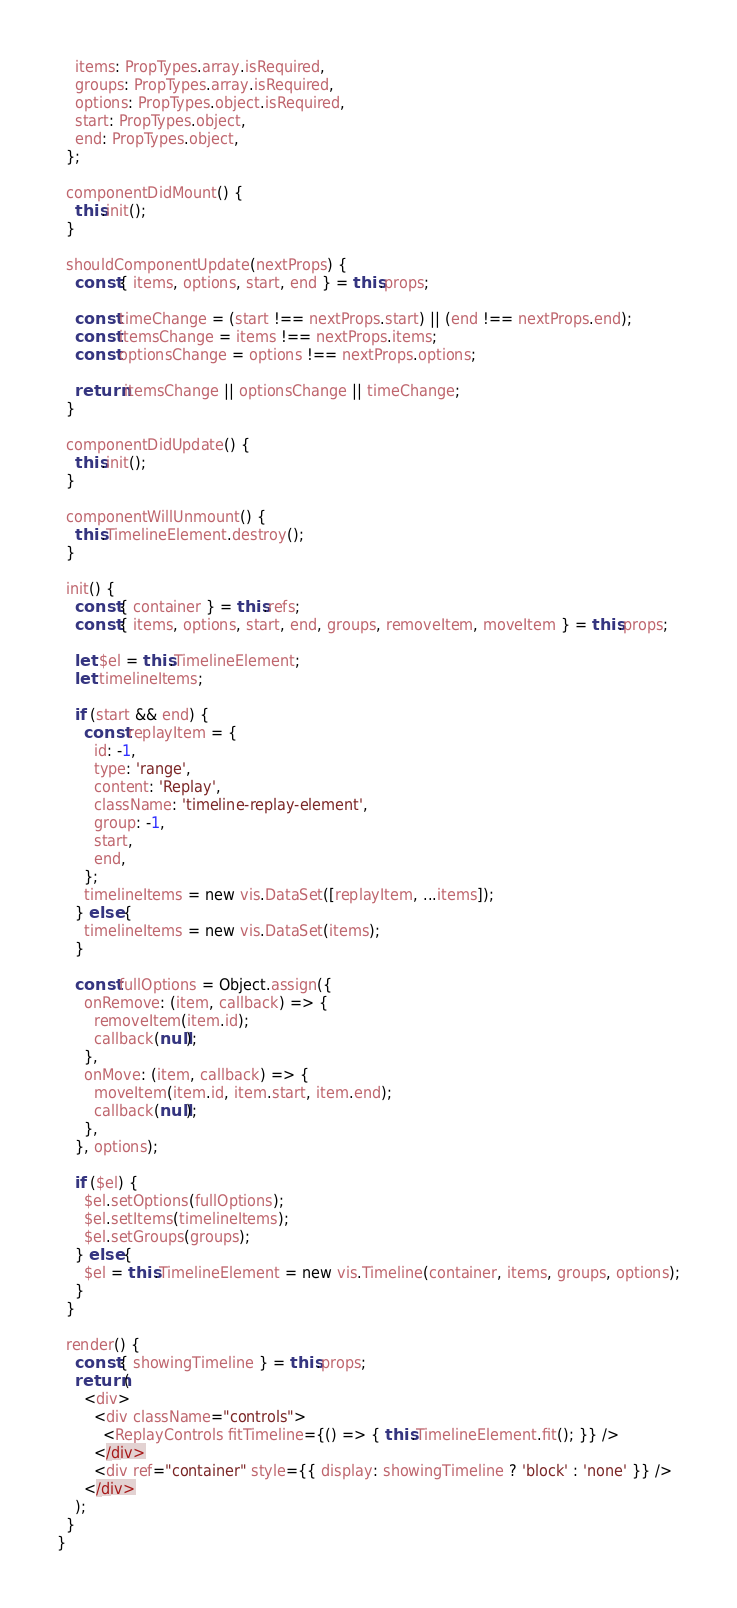<code> <loc_0><loc_0><loc_500><loc_500><_JavaScript_>    items: PropTypes.array.isRequired,
    groups: PropTypes.array.isRequired,
    options: PropTypes.object.isRequired,
    start: PropTypes.object,
    end: PropTypes.object,
  };

  componentDidMount() {
    this.init();
  }

  shouldComponentUpdate(nextProps) {
    const { items, options, start, end } = this.props;

    const timeChange = (start !== nextProps.start) || (end !== nextProps.end);
    const itemsChange = items !== nextProps.items;
    const optionsChange = options !== nextProps.options;

    return itemsChange || optionsChange || timeChange;
  }

  componentDidUpdate() {
    this.init();
  }

  componentWillUnmount() {
    this.TimelineElement.destroy();
  }

  init() {
    const { container } = this.refs;
    const { items, options, start, end, groups, removeItem, moveItem } = this.props;

    let $el = this.TimelineElement;
    let timelineItems;

    if (start && end) {
      const replayItem = {
        id: -1,
        type: 'range',
        content: 'Replay',
        className: 'timeline-replay-element',
        group: -1,
        start,
        end,
      };
      timelineItems = new vis.DataSet([replayItem, ...items]);
    } else {
      timelineItems = new vis.DataSet(items);
    }

    const fullOptions = Object.assign({
      onRemove: (item, callback) => {
        removeItem(item.id);
        callback(null);
      },
      onMove: (item, callback) => {
        moveItem(item.id, item.start, item.end);
        callback(null);
      },
    }, options);

    if ($el) {
      $el.setOptions(fullOptions);
      $el.setItems(timelineItems);
      $el.setGroups(groups);
    } else {
      $el = this.TimelineElement = new vis.Timeline(container, items, groups, options);
    }
  }

  render() {
    const { showingTimeline } = this.props;
    return (
      <div>
        <div className="controls">
          <ReplayControls fitTimeline={() => { this.TimelineElement.fit(); }} />
        </div>
        <div ref="container" style={{ display: showingTimeline ? 'block' : 'none' }} />
      </div>
    );
  }
}
</code> 